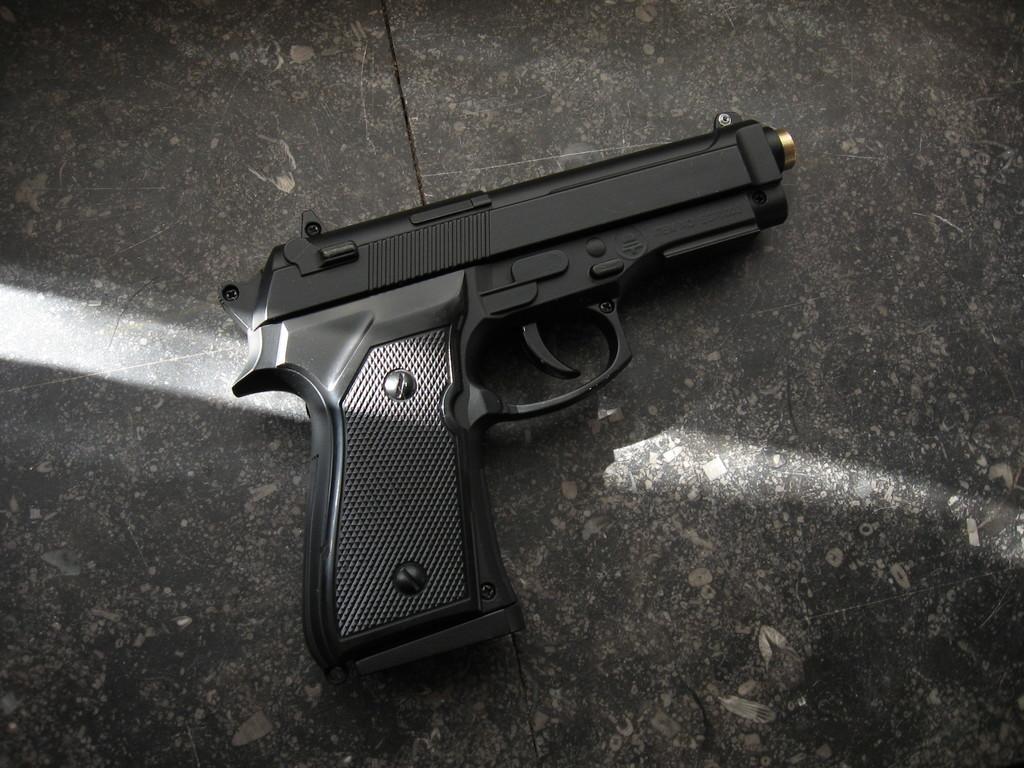Describe this image in one or two sentences. In this picture we can see a gun on a platform. 